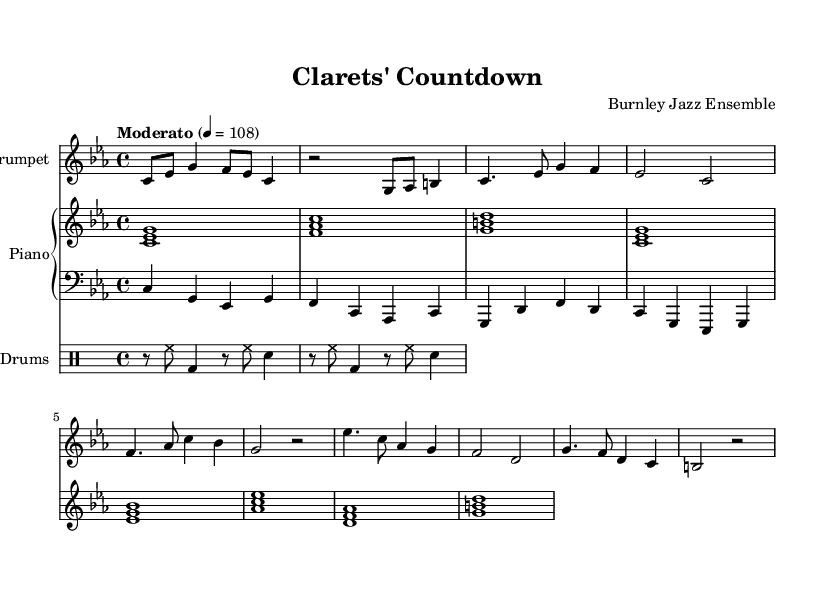What is the key signature of this music? The key signature is C minor, which has three flats. This can be identified by looking at the key signature indicated at the beginning of the staff.
Answer: C minor What is the time signature of this music? The time signature is 4/4, which indicates there are four beats in each measure and a quarter note receives one beat. This is indicated by the numbers displayed at the beginning of the sheet music.
Answer: 4/4 What is the tempo of this piece? The tempo is specified as Moderato, with a metronome marking of 108 beats per minute. This is indicated in the tempo marking shown on the score.
Answer: Moderato, 108 How many measures are there in the A section of the music? The A section contains four measures. By counting the measured segments that are labeled as the A section, it’s clear that there are four distinct measures.
Answer: 4 What type of ensemble is this piece intended for? The piece is intended for a jazz ensemble, as indicated by the header where it states "Burnley Jazz Ensemble." This indicates that it is arranged for a specific group typical in jazz music.
Answer: Jazz ensemble What is the main instrument featured in the score? The main instrument featured in the score is the trumpet, which has a dedicated staff and the first part written out. Looking at the score, it is easy to identify the importance given to the trumpet part.
Answer: Trumpet What characteristic distinguishes the piece as "cool jazz"? The piece features a relaxed and smooth playing style typical of cool jazz, without excessive improvisation. This style can often be identified through the moderate tempo and laid-back harmonic progression.
Answer: Relaxed style 